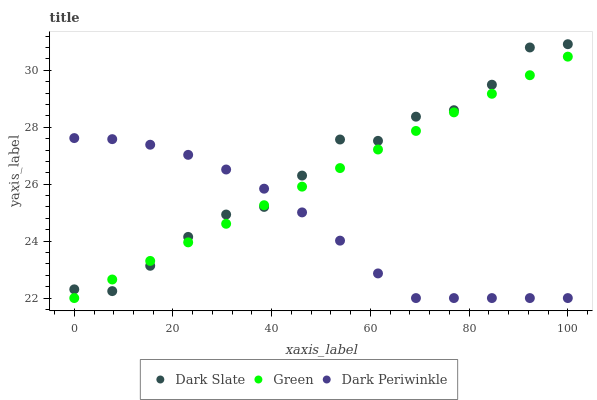Does Dark Periwinkle have the minimum area under the curve?
Answer yes or no. Yes. Does Dark Slate have the maximum area under the curve?
Answer yes or no. Yes. Does Green have the minimum area under the curve?
Answer yes or no. No. Does Green have the maximum area under the curve?
Answer yes or no. No. Is Green the smoothest?
Answer yes or no. Yes. Is Dark Slate the roughest?
Answer yes or no. Yes. Is Dark Periwinkle the smoothest?
Answer yes or no. No. Is Dark Periwinkle the roughest?
Answer yes or no. No. Does Green have the lowest value?
Answer yes or no. Yes. Does Dark Slate have the highest value?
Answer yes or no. Yes. Does Green have the highest value?
Answer yes or no. No. Does Green intersect Dark Periwinkle?
Answer yes or no. Yes. Is Green less than Dark Periwinkle?
Answer yes or no. No. Is Green greater than Dark Periwinkle?
Answer yes or no. No. 